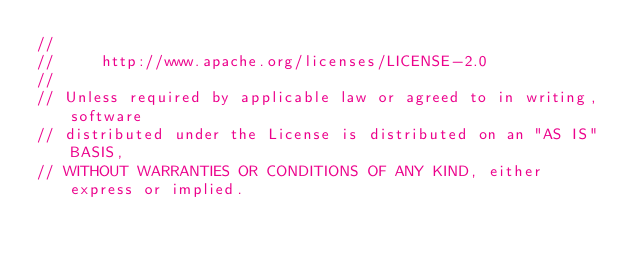Convert code to text. <code><loc_0><loc_0><loc_500><loc_500><_Go_>//
//     http://www.apache.org/licenses/LICENSE-2.0
//
// Unless required by applicable law or agreed to in writing, software
// distributed under the License is distributed on an "AS IS" BASIS,
// WITHOUT WARRANTIES OR CONDITIONS OF ANY KIND, either express or implied.</code> 